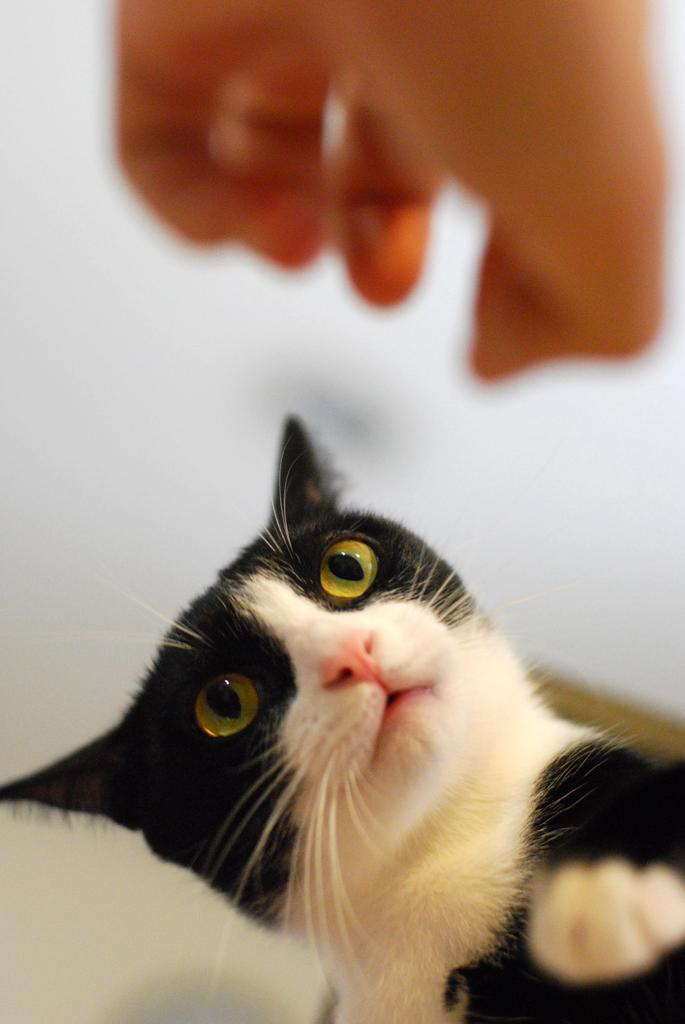What type of animal is in the image? There is a cat in the image. Can you see any part of a person in the image? Yes, the hand of a person is visible in the image. How would you describe the background of the image? The background of the image is blurred. How many frogs are jumping in the rainstorm in the image? There is no rainstorm or frogs present in the image; it features a cat and a blurred background. 